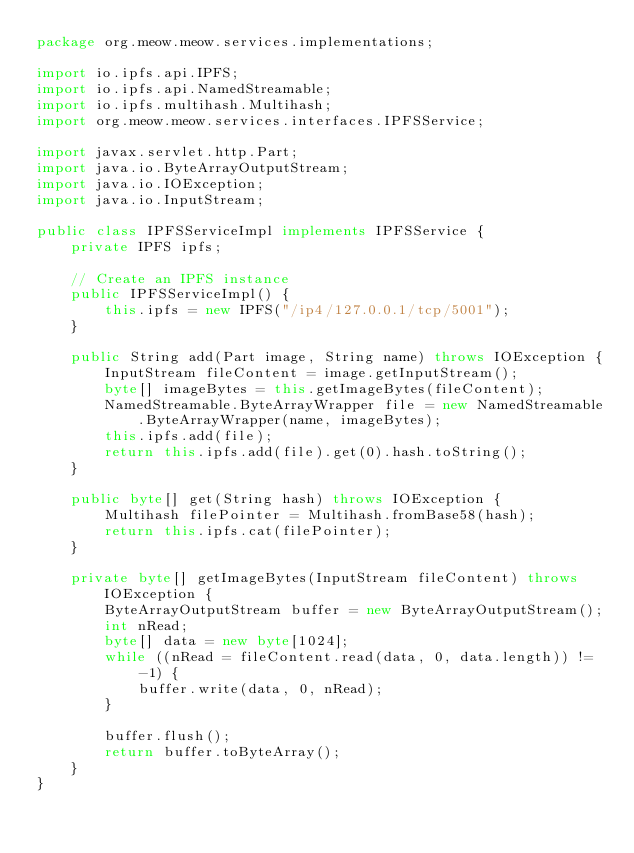Convert code to text. <code><loc_0><loc_0><loc_500><loc_500><_Java_>package org.meow.meow.services.implementations;

import io.ipfs.api.IPFS;
import io.ipfs.api.NamedStreamable;
import io.ipfs.multihash.Multihash;
import org.meow.meow.services.interfaces.IPFSService;

import javax.servlet.http.Part;
import java.io.ByteArrayOutputStream;
import java.io.IOException;
import java.io.InputStream;

public class IPFSServiceImpl implements IPFSService {
    private IPFS ipfs;

    // Create an IPFS instance
    public IPFSServiceImpl() {
        this.ipfs = new IPFS("/ip4/127.0.0.1/tcp/5001");
    }

    public String add(Part image, String name) throws IOException {
        InputStream fileContent = image.getInputStream();
        byte[] imageBytes = this.getImageBytes(fileContent);
        NamedStreamable.ByteArrayWrapper file = new NamedStreamable.ByteArrayWrapper(name, imageBytes);
        this.ipfs.add(file);
        return this.ipfs.add(file).get(0).hash.toString();
    }

    public byte[] get(String hash) throws IOException {
        Multihash filePointer = Multihash.fromBase58(hash);
        return this.ipfs.cat(filePointer);
    }

    private byte[] getImageBytes(InputStream fileContent) throws IOException {
        ByteArrayOutputStream buffer = new ByteArrayOutputStream();
        int nRead;
        byte[] data = new byte[1024];
        while ((nRead = fileContent.read(data, 0, data.length)) != -1) {
            buffer.write(data, 0, nRead);
        }

        buffer.flush();
        return buffer.toByteArray();
    }
}</code> 